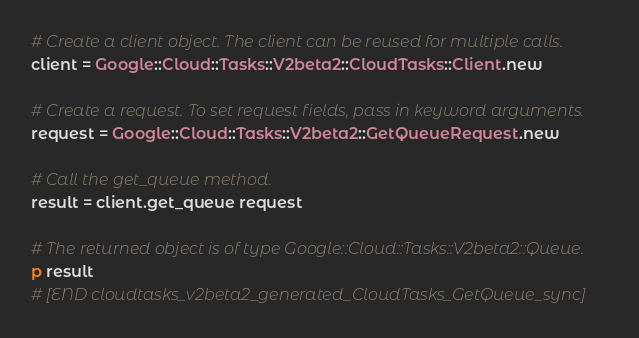<code> <loc_0><loc_0><loc_500><loc_500><_Ruby_># Create a client object. The client can be reused for multiple calls.
client = Google::Cloud::Tasks::V2beta2::CloudTasks::Client.new

# Create a request. To set request fields, pass in keyword arguments.
request = Google::Cloud::Tasks::V2beta2::GetQueueRequest.new

# Call the get_queue method.
result = client.get_queue request

# The returned object is of type Google::Cloud::Tasks::V2beta2::Queue.
p result
# [END cloudtasks_v2beta2_generated_CloudTasks_GetQueue_sync]
</code> 